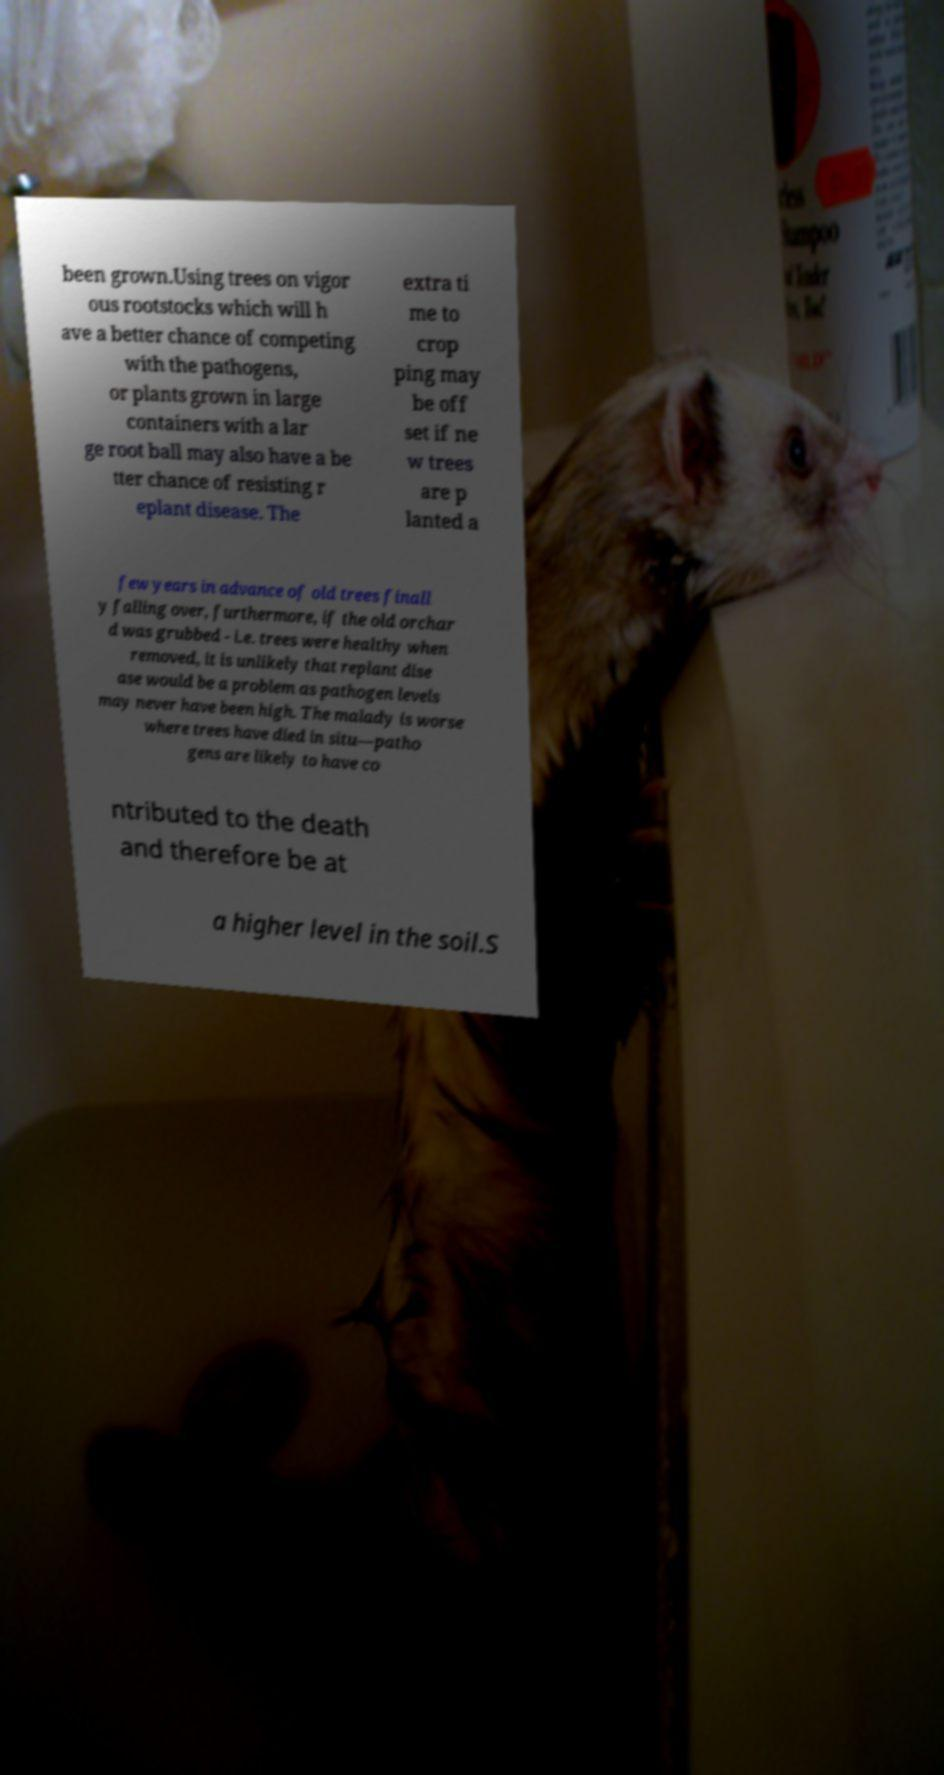Could you extract and type out the text from this image? been grown.Using trees on vigor ous rootstocks which will h ave a better chance of competing with the pathogens, or plants grown in large containers with a lar ge root ball may also have a be tter chance of resisting r eplant disease. The extra ti me to crop ping may be off set if ne w trees are p lanted a few years in advance of old trees finall y falling over, furthermore, if the old orchar d was grubbed - i.e. trees were healthy when removed, it is unlikely that replant dise ase would be a problem as pathogen levels may never have been high. The malady is worse where trees have died in situ—patho gens are likely to have co ntributed to the death and therefore be at a higher level in the soil.S 